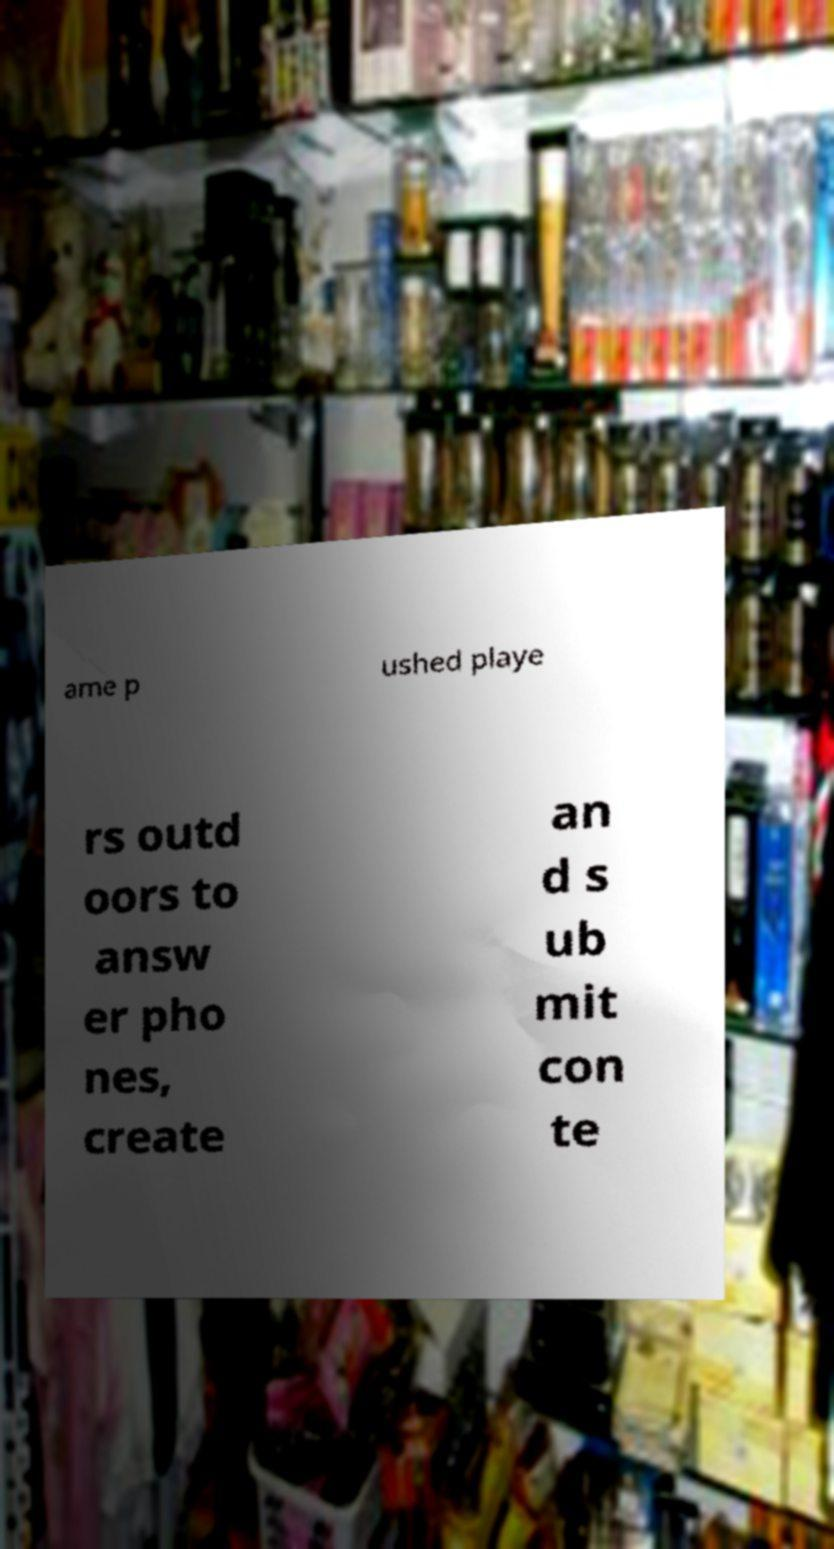For documentation purposes, I need the text within this image transcribed. Could you provide that? ame p ushed playe rs outd oors to answ er pho nes, create an d s ub mit con te 